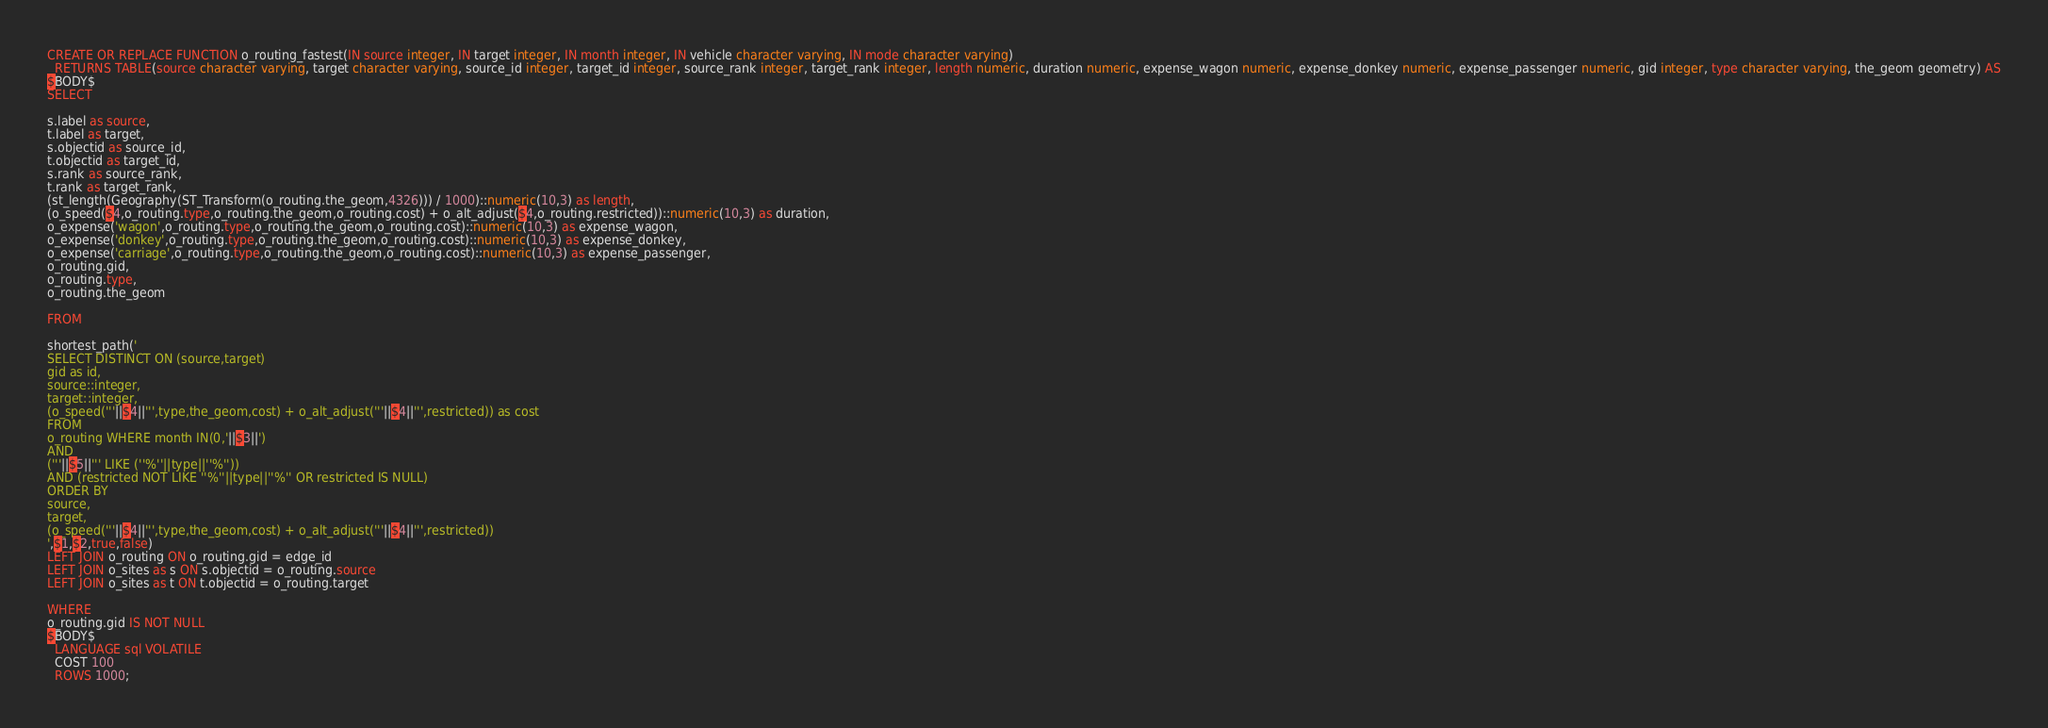<code> <loc_0><loc_0><loc_500><loc_500><_SQL_>CREATE OR REPLACE FUNCTION o_routing_fastest(IN source integer, IN target integer, IN month integer, IN vehicle character varying, IN mode character varying)
  RETURNS TABLE(source character varying, target character varying, source_id integer, target_id integer, source_rank integer, target_rank integer, length numeric, duration numeric, expense_wagon numeric, expense_donkey numeric, expense_passenger numeric, gid integer, type character varying, the_geom geometry) AS
$BODY$
SELECT

s.label as source,
t.label as target,
s.objectid as source_id,
t.objectid as target_id,
s.rank as source_rank,
t.rank as target_rank,
(st_length(Geography(ST_Transform(o_routing.the_geom,4326))) / 1000)::numeric(10,3) as length,
(o_speed($4,o_routing.type,o_routing.the_geom,o_routing.cost) + o_alt_adjust($4,o_routing.restricted))::numeric(10,3) as duration,
o_expense('wagon',o_routing.type,o_routing.the_geom,o_routing.cost)::numeric(10,3) as expense_wagon,
o_expense('donkey',o_routing.type,o_routing.the_geom,o_routing.cost)::numeric(10,3) as expense_donkey,
o_expense('carriage',o_routing.type,o_routing.the_geom,o_routing.cost)::numeric(10,3) as expense_passenger,
o_routing.gid,
o_routing.type,
o_routing.the_geom

FROM

shortest_path('
SELECT DISTINCT ON (source,target)
gid as id,
source::integer,
target::integer,
(o_speed('''||$4||''',type,the_geom,cost) + o_alt_adjust('''||$4||''',restricted)) as cost
FROM
o_routing WHERE month IN(0,'||$3||')
AND 
('''||$5||''' LIKE (''%''||type||''%''))
AND (restricted NOT LIKE ''%''||type||''%'' OR restricted IS NULL) 
ORDER BY
source,
target,
(o_speed('''||$4||''',type,the_geom,cost) + o_alt_adjust('''||$4||''',restricted))
',$1,$2,true,false)
LEFT JOIN o_routing ON o_routing.gid = edge_id
LEFT JOIN o_sites as s ON s.objectid = o_routing.source
LEFT JOIN o_sites as t ON t.objectid = o_routing.target

WHERE
o_routing.gid IS NOT NULL
$BODY$
  LANGUAGE sql VOLATILE
  COST 100
  ROWS 1000;</code> 